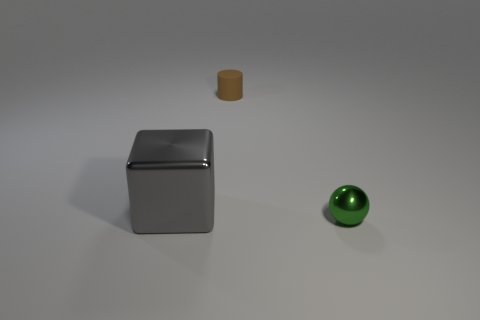Is there anything else that has the same shape as the gray metal object?
Provide a short and direct response. No. How many things are behind the small green shiny ball and in front of the small brown rubber object?
Give a very brief answer. 1. There is a brown object; is its shape the same as the shiny thing on the left side of the small brown cylinder?
Give a very brief answer. No. Is the number of brown matte cylinders that are on the left side of the large gray object greater than the number of big gray metallic things?
Offer a terse response. No. Is the number of gray metallic things that are in front of the small metal ball less than the number of big brown shiny cubes?
Keep it short and to the point. No. What number of tiny balls have the same color as the matte object?
Offer a terse response. 0. There is a object that is both behind the ball and right of the big metallic object; what material is it?
Make the answer very short. Rubber. There is a shiny thing that is left of the green thing; is it the same color as the object that is behind the big metal object?
Give a very brief answer. No. How many blue things are small objects or small cylinders?
Your answer should be very brief. 0. Is the number of cubes that are on the right side of the tiny brown matte cylinder less than the number of balls that are on the left side of the small metallic sphere?
Your answer should be compact. No. 